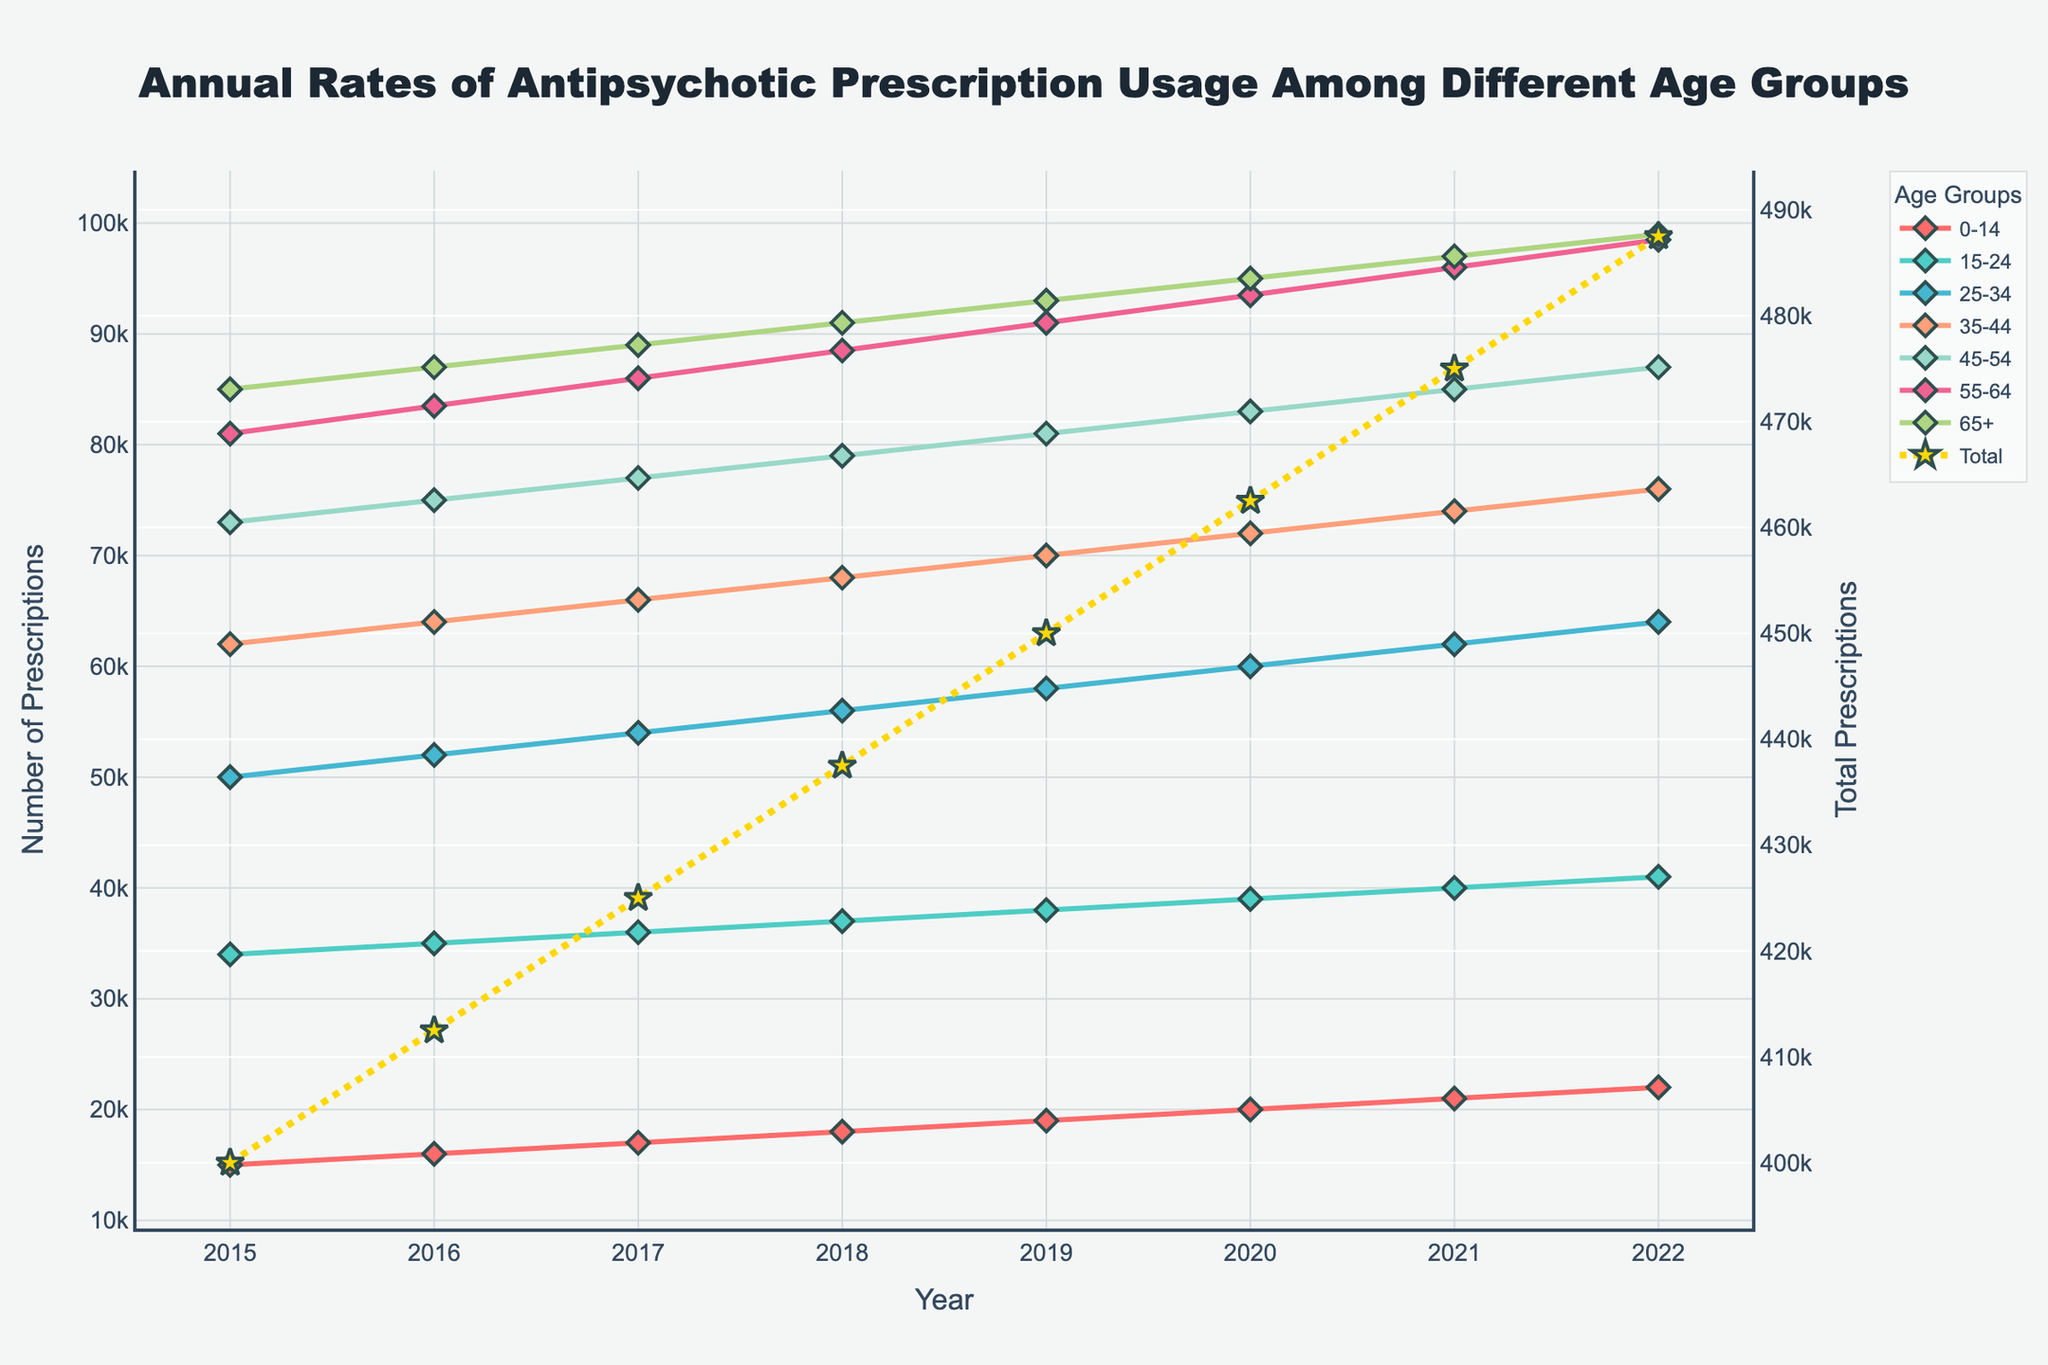What are the age groups included in the figure? The age groups are indicated by lines of different colors in the plot. By examining the legend, we can identify all the age groups represented.
Answer: 0-14, 15-24, 25-34, 35-44, 45-54, 55-64, 65+ Which age group had the highest number of prescriptions in 2022? To determine this, we should look at the points corresponding to 2022 on the x-axis and identify which data series has the highest value.
Answer: 65+ How did the total number of antipsychotic prescriptions change from 2015 to 2022? We analyze the secondary y-axis that represents the total prescriptions. By comparing the value at 2015 and at 2022, we can see if it increased, decreased, or stayed the same.
Answer: Increased What is the trend of antipsychotic prescriptions for the 0-14 age group from 2015 to 2022? Look at the line representing the 0-14 age group and determine the general direction (increasing, decreasing, or stable) over the years.
Answer: Increasing Compare the slopes of the trend lines for the 25-34 and 55-64 age groups. Which age group shows a faster rate of increase? Observe the steepness of the lines for the 25-34 and 55-64 groups. The steeper the line, the faster the rate of increase.
Answer: 55-64 What was the percentage increase in total prescriptions from 2015 to 2022? First, find the total prescriptions for both years. Calculate the difference and divide by the 2015 value, then multiply by 100 to get the percentage.
Answer: ((510500 - 362000)/362000) * 100 ≈ 41.04% Has any age group exhibited a decrease in prescription rates over the timeline? Examine each age group's line to see if any line trends downward at any point from 2015 to 2022.
Answer: No Which age group had the smallest change in prescription rates from 2015 to 2022? Determine the difference between the 2022 and 2015 values for each age group, and identify the group with the smallest difference.
Answer: 0-14 During which year did the 45-54 age group have the highest increase in prescriptions compared to the previous year? Calculate the difference in prescription numbers year-over-year and identify the year with the largest increase for 45-54.
Answer: 2015-2016 